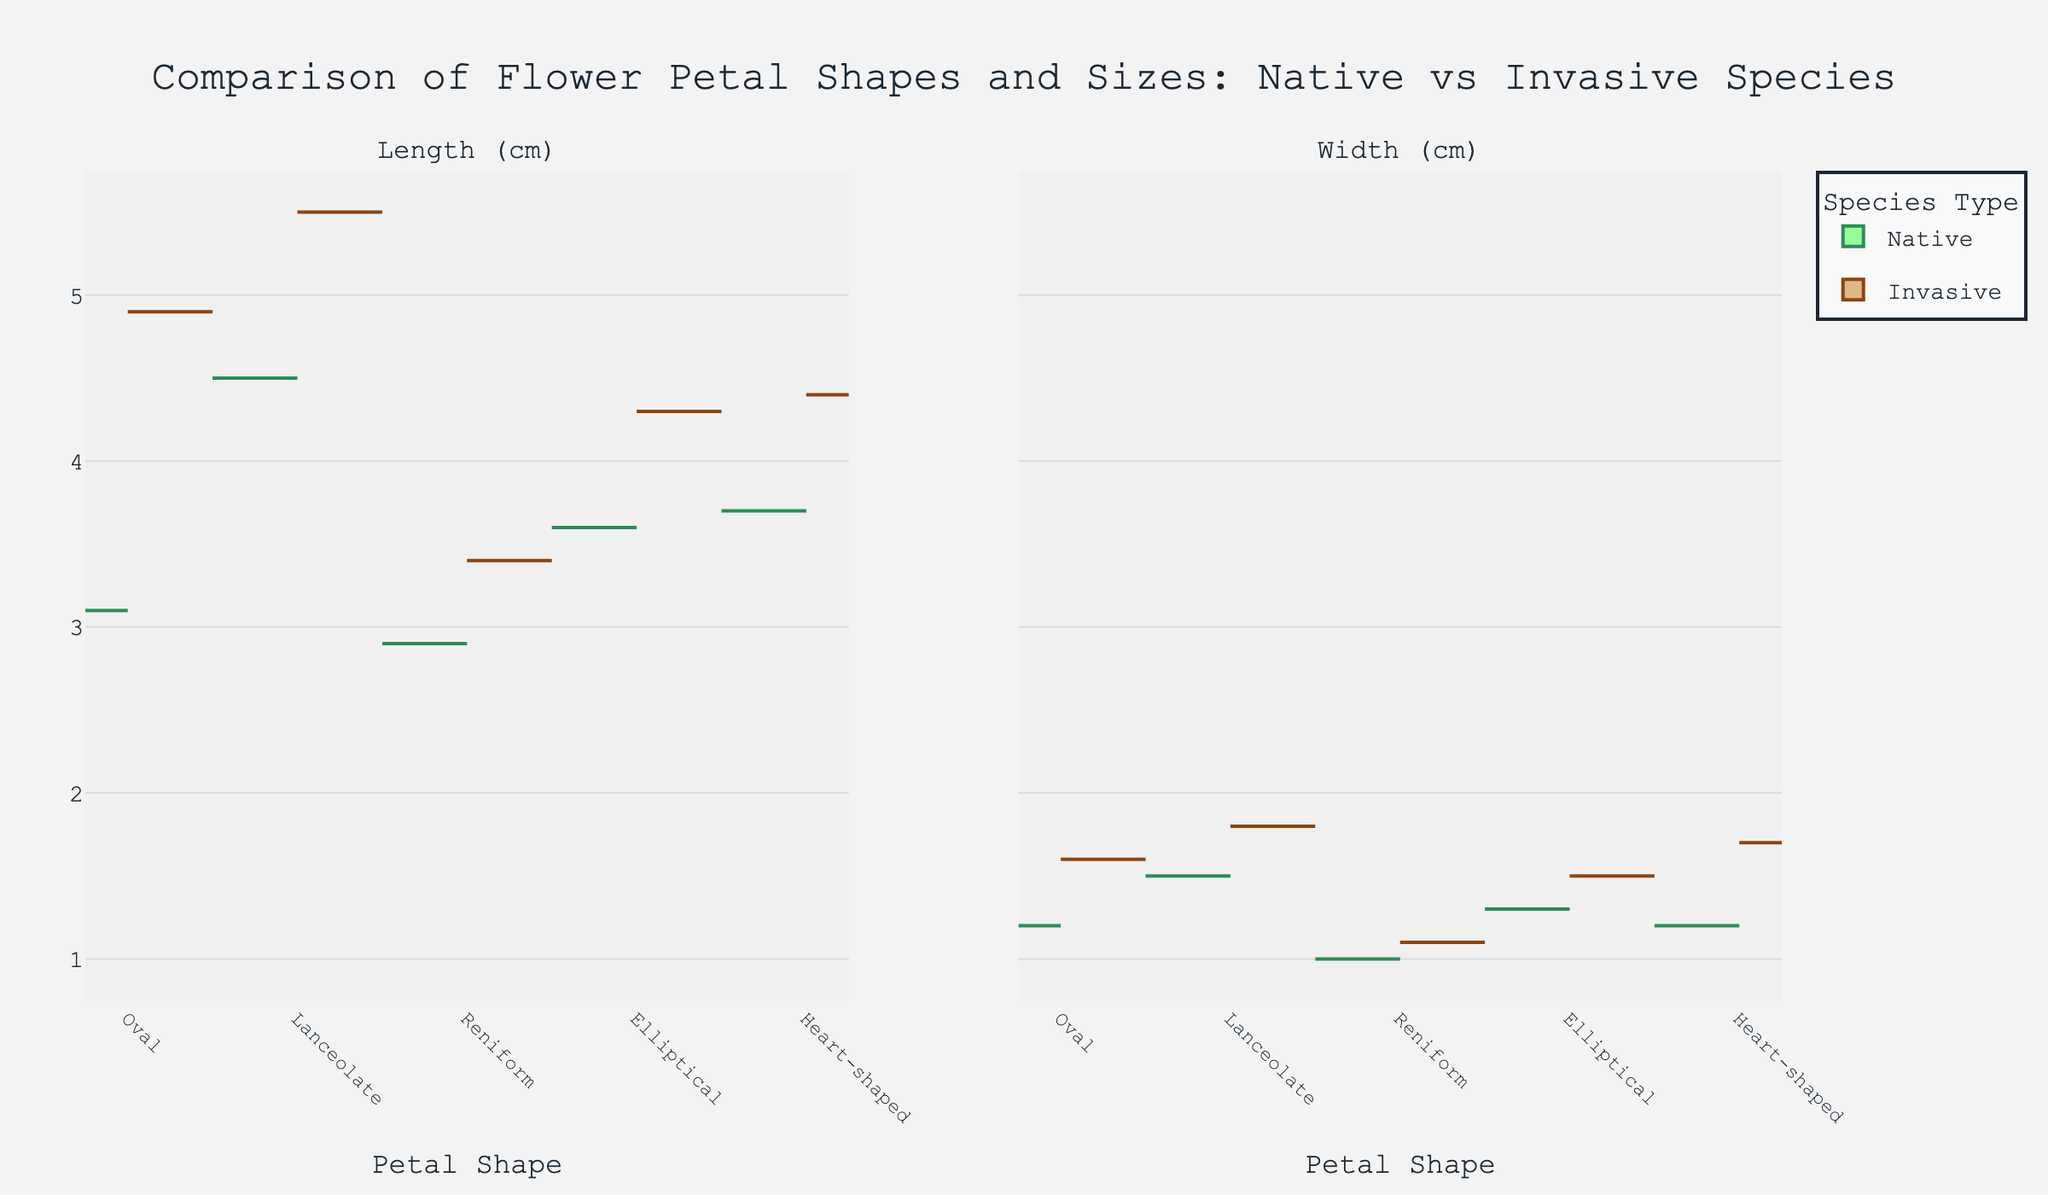what is the title of the figure? The title of the plot is located at the top and usually serves to summarize the main idea of the visualization. In this figure, the title reads, "Comparison of Flower Petal Shapes and Sizes: Native vs Invasive Species".
Answer: Comparison of Flower Petal Shapes and Sizes: Native vs Invasive Species Which petal shape has the highest average length for invasive species? In the plot, invasive species are represented on the right side of each violin plot. Among invasive species, the "Lanceolate" petal shape shows the highest average length, as it extends the furthest to the right.
Answer: Lanceolate What are the axis labels in this figure? The X-axis label is "Petal Shape", which lists various petal shapes (Oval, Lanceolate, Reniform, Elliptical, Heart-shaped). The Y-axis doesn't have a specific label but represents the measurements "Length (cm)" on the left and "Width (cm)" on the right.
Answer: X-axis: Petal Shape Which species type generally has longer petal lengths for the "Oval" shape? In the left violin plot featuring length, the average length of the petals for each species type of the "Oval" shape can be compared. The invasive species (right side) exhibit longer average petal lengths than native species (left side) for the "Oval" shape.
Answer: Invasive Which petal shape shows the smallest width for native species? In the right violin plot representing petal width, native species are shown on the left side. The "Reniform" petal shape has the smallest width among native species as it is the shortest/compressed plot on the left side.
Answer: Reniform Which has a greater difference in average length between native and invasive species: Elliptical or Heart-shaped petals? By comparing the native and invasive lengths on the left violin plot, the difference in the average lengths for "Elliptical" can be seen as smaller than for "Heart-shaped." Hence, "Heart-shaped" petals show a greater difference.
Answer: Heart-shaped What are the colors representing native and invasive species in the figure? The native species are represented with green colors (border: dark green, fill: light green), whereas the invasive species are represented with brown colors (border: brown, fill: light brown). These color schemes help differentiate between the two species types in the figure.
Answer: Native: Green, Invasive: Brown How does the average width of "Heart-shaped" petals compare between native and invasive species? In the right violin plot for width, by comparing both sides for "Heart-shaped", it is seen that invasive species have wider petals than native species.
Answer: Invasive species have wider "Heart-shaped" petals than native species 